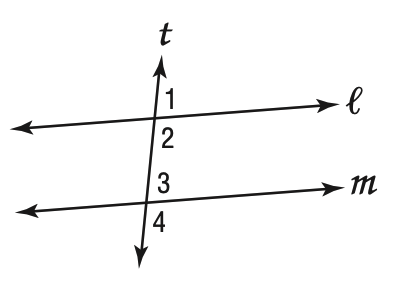Question: In the figure at the right, which cannot be true if m \parallel l and m \angle 1 = 73?
Choices:
A. \angle 1 \cong \angle 4
B. \angle 3 \cong \angle 1
C. m \angle 2 + m \angle 3 = 180
D. m \angle 4 > 73
Answer with the letter. Answer: A 